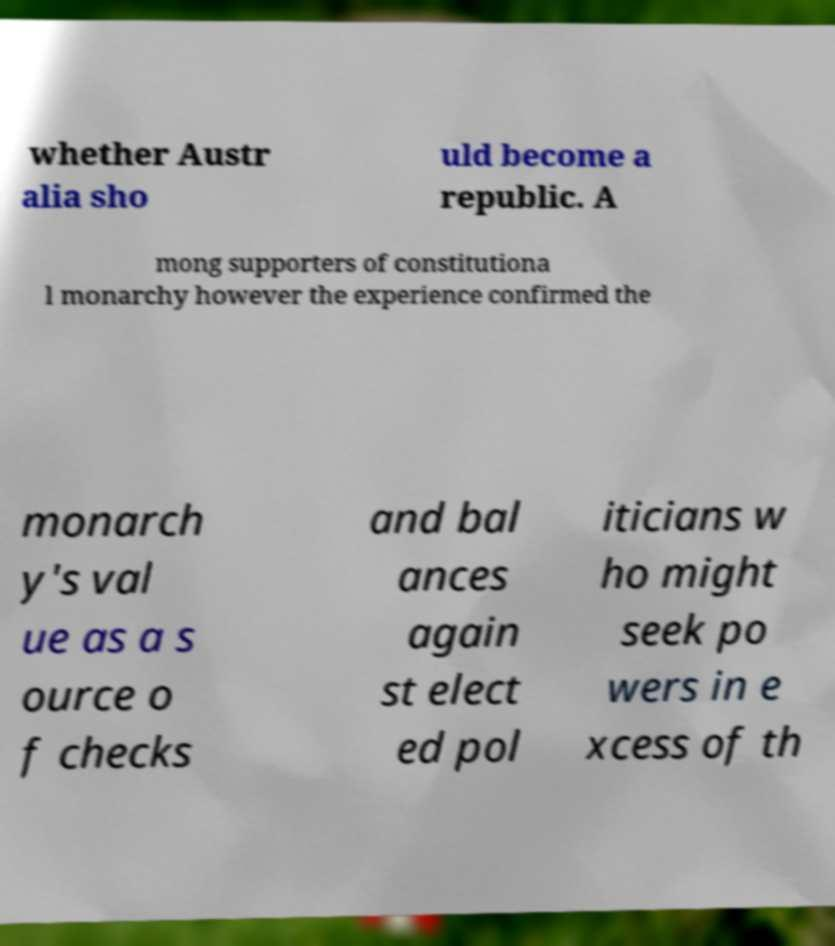There's text embedded in this image that I need extracted. Can you transcribe it verbatim? whether Austr alia sho uld become a republic. A mong supporters of constitutiona l monarchy however the experience confirmed the monarch y's val ue as a s ource o f checks and bal ances again st elect ed pol iticians w ho might seek po wers in e xcess of th 